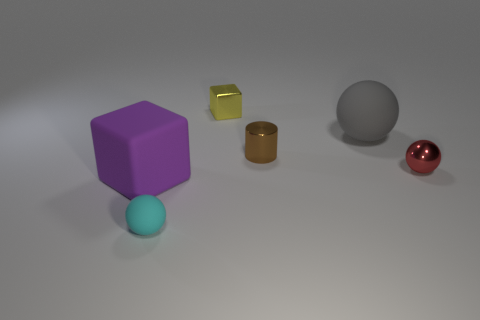Subtract all gray balls. Subtract all cyan cylinders. How many balls are left? 2 Add 3 small yellow metallic objects. How many objects exist? 9 Subtract all cylinders. How many objects are left? 5 Subtract 1 purple blocks. How many objects are left? 5 Subtract all small cyan balls. Subtract all tiny spheres. How many objects are left? 3 Add 3 large matte balls. How many large matte balls are left? 4 Add 6 big rubber blocks. How many big rubber blocks exist? 7 